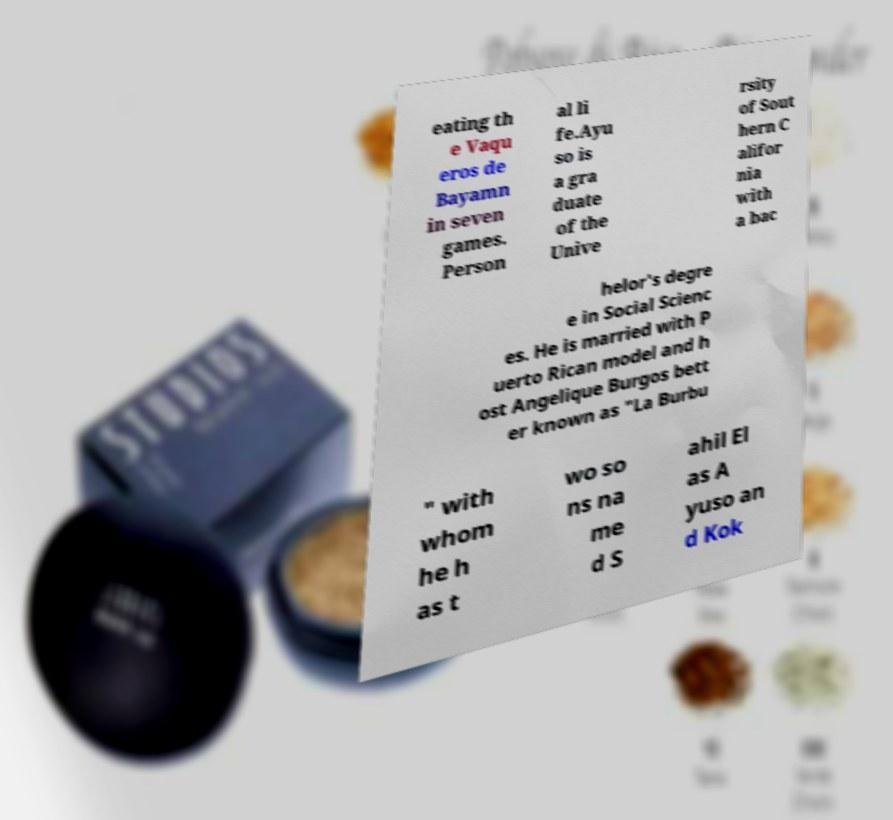Could you assist in decoding the text presented in this image and type it out clearly? eating th e Vaqu eros de Bayamn in seven games. Person al li fe.Ayu so is a gra duate of the Unive rsity of Sout hern C alifor nia with a bac helor's degre e in Social Scienc es. He is married with P uerto Rican model and h ost Angelique Burgos bett er known as "La Burbu " with whom he h as t wo so ns na me d S ahil El as A yuso an d Kok 